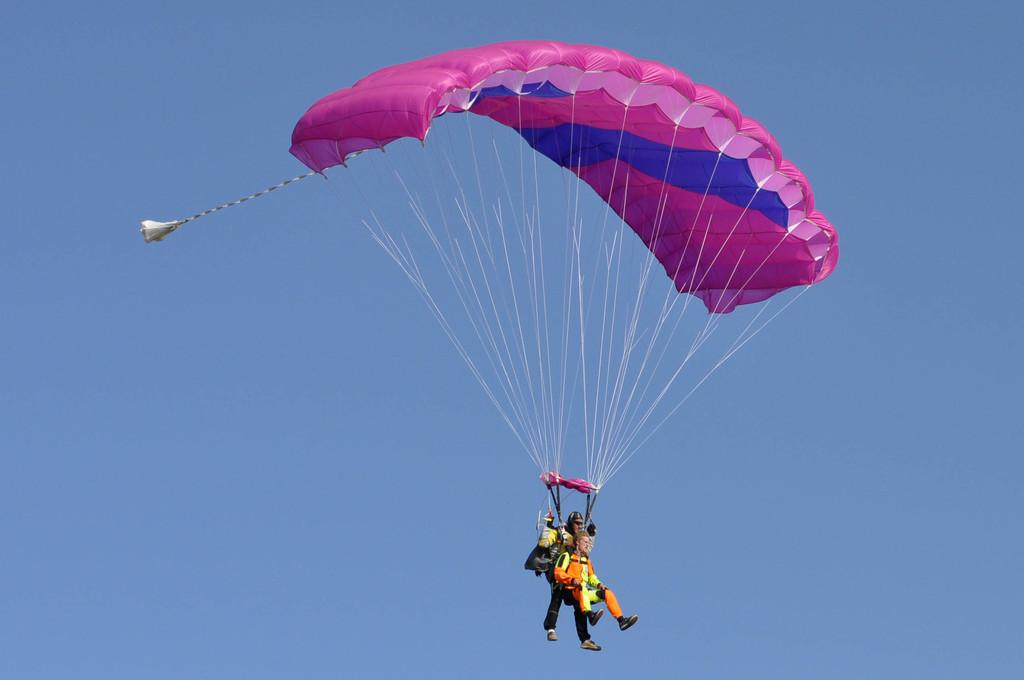How many people are in the image? There are two persons in the picture. What is one of the persons holding? One of the persons is holding a parachute. What colors can be seen on the parachute? The parachute has pink and blue colors. What is the condition of the sky in the image? The sky is clear in the image. Can you tell me how many potatoes are visible in the image? There are no potatoes present in the image. What type of snails can be seen crawling on the parachute? There are no snails present in the image; only the two persons and the parachute are visible. 